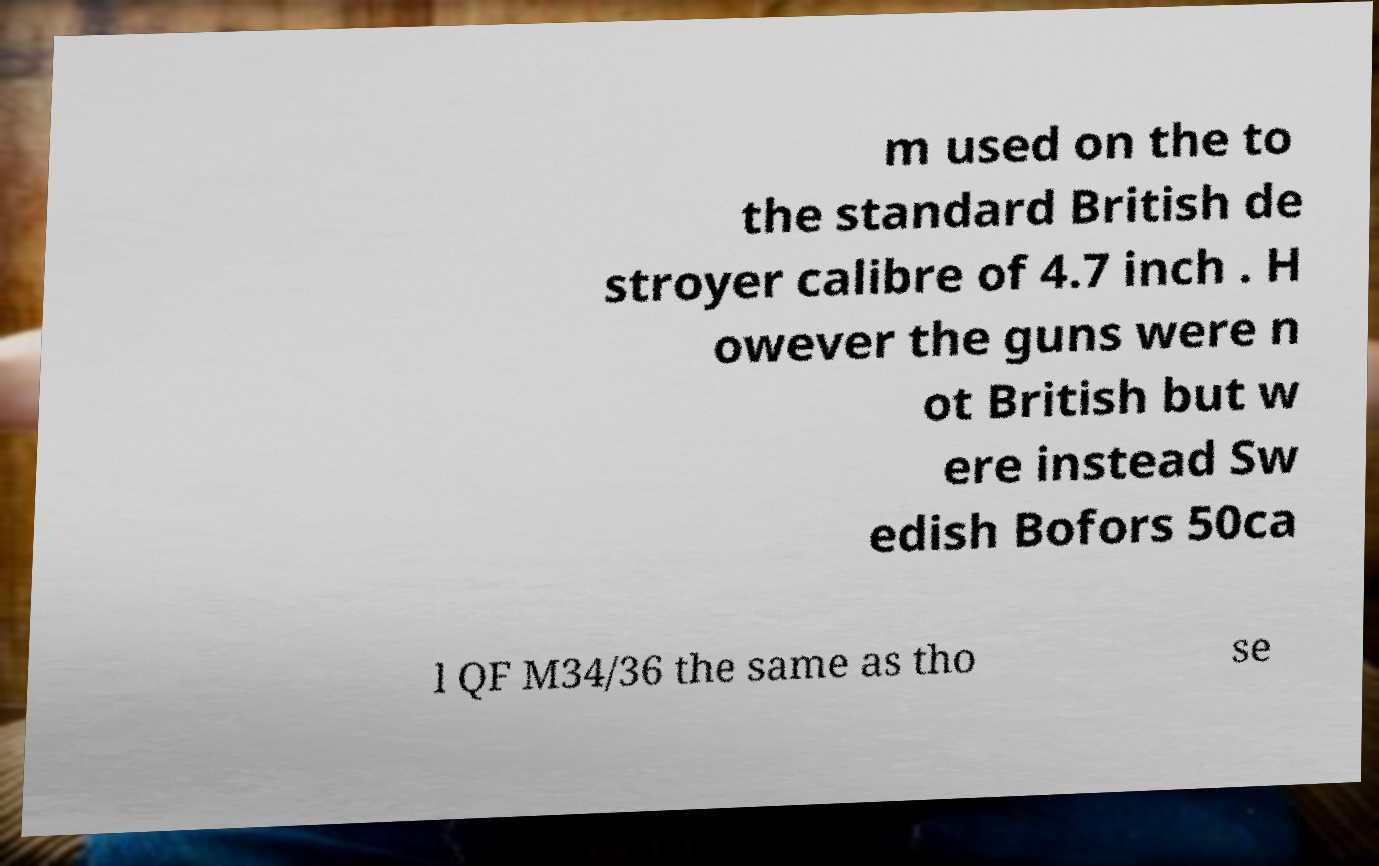Could you extract and type out the text from this image? m used on the to the standard British de stroyer calibre of 4.7 inch . H owever the guns were n ot British but w ere instead Sw edish Bofors 50ca l QF M34/36 the same as tho se 